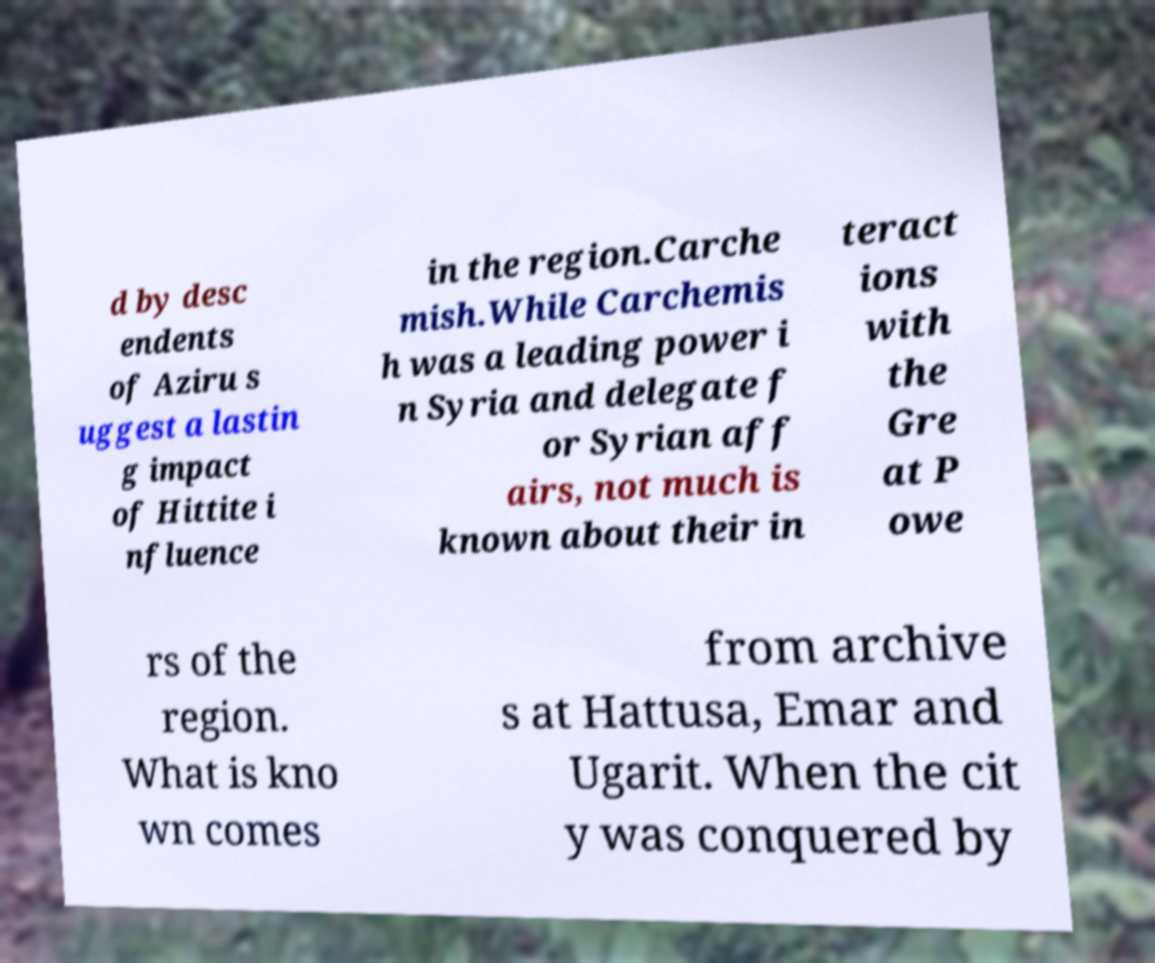Please identify and transcribe the text found in this image. d by desc endents of Aziru s uggest a lastin g impact of Hittite i nfluence in the region.Carche mish.While Carchemis h was a leading power i n Syria and delegate f or Syrian aff airs, not much is known about their in teract ions with the Gre at P owe rs of the region. What is kno wn comes from archive s at Hattusa, Emar and Ugarit. When the cit y was conquered by 